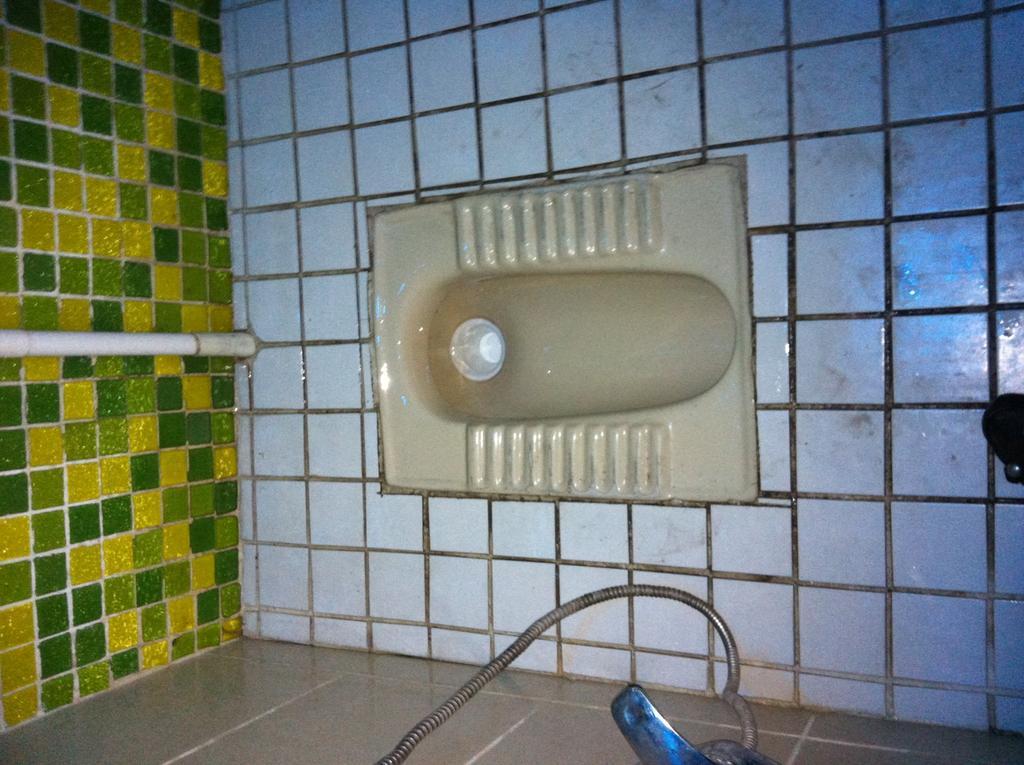Can you describe this image briefly? In this picture we can see the inside view of the toilet. In the front there is a toilet seat with white flooring tiles. On the top there are yellow and green color cladding tile on the wall. 